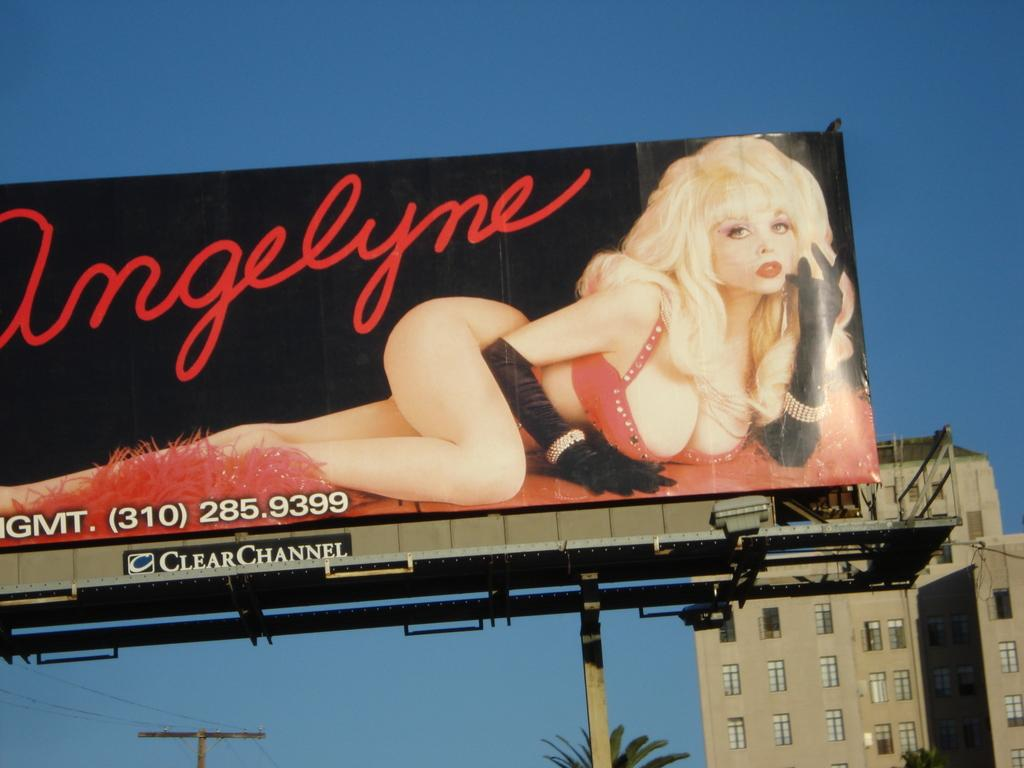<image>
Describe the image concisely. Billboard showing a woman and the number 3102859399 on the bottom. 